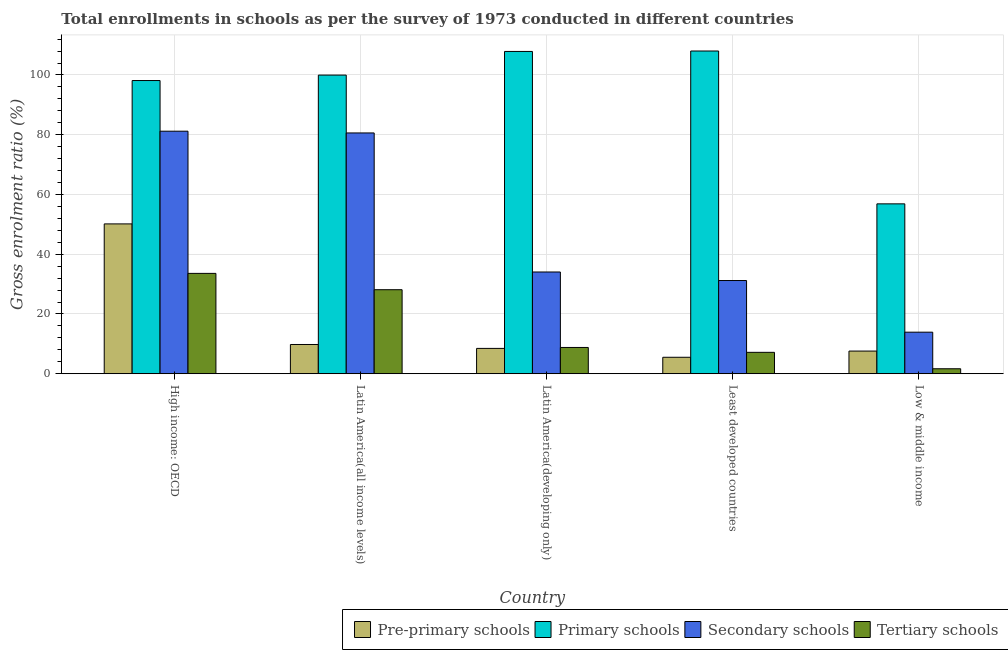How many different coloured bars are there?
Your answer should be very brief. 4. Are the number of bars per tick equal to the number of legend labels?
Offer a very short reply. Yes. Are the number of bars on each tick of the X-axis equal?
Your response must be concise. Yes. What is the label of the 3rd group of bars from the left?
Your response must be concise. Latin America(developing only). What is the gross enrolment ratio in secondary schools in High income: OECD?
Offer a very short reply. 81.17. Across all countries, what is the maximum gross enrolment ratio in primary schools?
Your response must be concise. 108.01. Across all countries, what is the minimum gross enrolment ratio in secondary schools?
Give a very brief answer. 13.91. In which country was the gross enrolment ratio in secondary schools maximum?
Your answer should be very brief. High income: OECD. In which country was the gross enrolment ratio in pre-primary schools minimum?
Make the answer very short. Least developed countries. What is the total gross enrolment ratio in secondary schools in the graph?
Offer a very short reply. 240.93. What is the difference between the gross enrolment ratio in secondary schools in High income: OECD and that in Least developed countries?
Your response must be concise. 49.98. What is the difference between the gross enrolment ratio in pre-primary schools in High income: OECD and the gross enrolment ratio in secondary schools in Latin America(developing only)?
Provide a short and direct response. 16.1. What is the average gross enrolment ratio in pre-primary schools per country?
Your response must be concise. 16.3. What is the difference between the gross enrolment ratio in secondary schools and gross enrolment ratio in tertiary schools in Latin America(all income levels)?
Provide a succinct answer. 52.47. What is the ratio of the gross enrolment ratio in primary schools in High income: OECD to that in Least developed countries?
Give a very brief answer. 0.91. Is the difference between the gross enrolment ratio in pre-primary schools in Latin America(all income levels) and Least developed countries greater than the difference between the gross enrolment ratio in tertiary schools in Latin America(all income levels) and Least developed countries?
Your answer should be compact. No. What is the difference between the highest and the second highest gross enrolment ratio in secondary schools?
Offer a terse response. 0.58. What is the difference between the highest and the lowest gross enrolment ratio in tertiary schools?
Ensure brevity in your answer.  31.92. Is the sum of the gross enrolment ratio in primary schools in High income: OECD and Least developed countries greater than the maximum gross enrolment ratio in secondary schools across all countries?
Your response must be concise. Yes. Is it the case that in every country, the sum of the gross enrolment ratio in primary schools and gross enrolment ratio in tertiary schools is greater than the sum of gross enrolment ratio in secondary schools and gross enrolment ratio in pre-primary schools?
Offer a very short reply. Yes. What does the 1st bar from the left in High income: OECD represents?
Ensure brevity in your answer.  Pre-primary schools. What does the 4th bar from the right in Latin America(all income levels) represents?
Keep it short and to the point. Pre-primary schools. How many countries are there in the graph?
Your response must be concise. 5. Does the graph contain any zero values?
Your answer should be very brief. No. Does the graph contain grids?
Make the answer very short. Yes. Where does the legend appear in the graph?
Make the answer very short. Bottom right. How are the legend labels stacked?
Keep it short and to the point. Horizontal. What is the title of the graph?
Keep it short and to the point. Total enrollments in schools as per the survey of 1973 conducted in different countries. What is the label or title of the X-axis?
Your response must be concise. Country. What is the Gross enrolment ratio (%) of Pre-primary schools in High income: OECD?
Your answer should be very brief. 50.15. What is the Gross enrolment ratio (%) in Primary schools in High income: OECD?
Provide a succinct answer. 98.13. What is the Gross enrolment ratio (%) in Secondary schools in High income: OECD?
Your answer should be very brief. 81.17. What is the Gross enrolment ratio (%) of Tertiary schools in High income: OECD?
Offer a very short reply. 33.59. What is the Gross enrolment ratio (%) of Pre-primary schools in Latin America(all income levels)?
Your answer should be very brief. 9.79. What is the Gross enrolment ratio (%) of Primary schools in Latin America(all income levels)?
Provide a succinct answer. 99.96. What is the Gross enrolment ratio (%) of Secondary schools in Latin America(all income levels)?
Provide a succinct answer. 80.59. What is the Gross enrolment ratio (%) in Tertiary schools in Latin America(all income levels)?
Offer a terse response. 28.12. What is the Gross enrolment ratio (%) of Pre-primary schools in Latin America(developing only)?
Make the answer very short. 8.48. What is the Gross enrolment ratio (%) of Primary schools in Latin America(developing only)?
Your response must be concise. 107.87. What is the Gross enrolment ratio (%) in Secondary schools in Latin America(developing only)?
Your answer should be very brief. 34.05. What is the Gross enrolment ratio (%) of Tertiary schools in Latin America(developing only)?
Make the answer very short. 8.79. What is the Gross enrolment ratio (%) in Pre-primary schools in Least developed countries?
Your answer should be compact. 5.51. What is the Gross enrolment ratio (%) in Primary schools in Least developed countries?
Provide a short and direct response. 108.01. What is the Gross enrolment ratio (%) in Secondary schools in Least developed countries?
Give a very brief answer. 31.2. What is the Gross enrolment ratio (%) in Tertiary schools in Least developed countries?
Give a very brief answer. 7.16. What is the Gross enrolment ratio (%) in Pre-primary schools in Low & middle income?
Keep it short and to the point. 7.59. What is the Gross enrolment ratio (%) in Primary schools in Low & middle income?
Provide a short and direct response. 56.86. What is the Gross enrolment ratio (%) in Secondary schools in Low & middle income?
Your answer should be very brief. 13.91. What is the Gross enrolment ratio (%) in Tertiary schools in Low & middle income?
Offer a terse response. 1.67. Across all countries, what is the maximum Gross enrolment ratio (%) in Pre-primary schools?
Make the answer very short. 50.15. Across all countries, what is the maximum Gross enrolment ratio (%) of Primary schools?
Provide a succinct answer. 108.01. Across all countries, what is the maximum Gross enrolment ratio (%) of Secondary schools?
Give a very brief answer. 81.17. Across all countries, what is the maximum Gross enrolment ratio (%) of Tertiary schools?
Your answer should be compact. 33.59. Across all countries, what is the minimum Gross enrolment ratio (%) of Pre-primary schools?
Offer a very short reply. 5.51. Across all countries, what is the minimum Gross enrolment ratio (%) in Primary schools?
Offer a terse response. 56.86. Across all countries, what is the minimum Gross enrolment ratio (%) of Secondary schools?
Your answer should be very brief. 13.91. Across all countries, what is the minimum Gross enrolment ratio (%) in Tertiary schools?
Offer a terse response. 1.67. What is the total Gross enrolment ratio (%) in Pre-primary schools in the graph?
Make the answer very short. 81.51. What is the total Gross enrolment ratio (%) of Primary schools in the graph?
Make the answer very short. 470.83. What is the total Gross enrolment ratio (%) of Secondary schools in the graph?
Offer a terse response. 240.93. What is the total Gross enrolment ratio (%) of Tertiary schools in the graph?
Ensure brevity in your answer.  79.34. What is the difference between the Gross enrolment ratio (%) in Pre-primary schools in High income: OECD and that in Latin America(all income levels)?
Offer a terse response. 40.36. What is the difference between the Gross enrolment ratio (%) in Primary schools in High income: OECD and that in Latin America(all income levels)?
Make the answer very short. -1.83. What is the difference between the Gross enrolment ratio (%) of Secondary schools in High income: OECD and that in Latin America(all income levels)?
Your answer should be very brief. 0.58. What is the difference between the Gross enrolment ratio (%) in Tertiary schools in High income: OECD and that in Latin America(all income levels)?
Ensure brevity in your answer.  5.47. What is the difference between the Gross enrolment ratio (%) of Pre-primary schools in High income: OECD and that in Latin America(developing only)?
Provide a short and direct response. 41.67. What is the difference between the Gross enrolment ratio (%) in Primary schools in High income: OECD and that in Latin America(developing only)?
Provide a succinct answer. -9.74. What is the difference between the Gross enrolment ratio (%) of Secondary schools in High income: OECD and that in Latin America(developing only)?
Ensure brevity in your answer.  47.12. What is the difference between the Gross enrolment ratio (%) in Tertiary schools in High income: OECD and that in Latin America(developing only)?
Your answer should be compact. 24.8. What is the difference between the Gross enrolment ratio (%) of Pre-primary schools in High income: OECD and that in Least developed countries?
Ensure brevity in your answer.  44.64. What is the difference between the Gross enrolment ratio (%) of Primary schools in High income: OECD and that in Least developed countries?
Your answer should be very brief. -9.89. What is the difference between the Gross enrolment ratio (%) in Secondary schools in High income: OECD and that in Least developed countries?
Keep it short and to the point. 49.98. What is the difference between the Gross enrolment ratio (%) of Tertiary schools in High income: OECD and that in Least developed countries?
Ensure brevity in your answer.  26.43. What is the difference between the Gross enrolment ratio (%) of Pre-primary schools in High income: OECD and that in Low & middle income?
Your answer should be compact. 42.56. What is the difference between the Gross enrolment ratio (%) of Primary schools in High income: OECD and that in Low & middle income?
Offer a very short reply. 41.27. What is the difference between the Gross enrolment ratio (%) of Secondary schools in High income: OECD and that in Low & middle income?
Your answer should be compact. 67.27. What is the difference between the Gross enrolment ratio (%) of Tertiary schools in High income: OECD and that in Low & middle income?
Your answer should be very brief. 31.92. What is the difference between the Gross enrolment ratio (%) of Pre-primary schools in Latin America(all income levels) and that in Latin America(developing only)?
Your response must be concise. 1.31. What is the difference between the Gross enrolment ratio (%) in Primary schools in Latin America(all income levels) and that in Latin America(developing only)?
Your response must be concise. -7.91. What is the difference between the Gross enrolment ratio (%) in Secondary schools in Latin America(all income levels) and that in Latin America(developing only)?
Make the answer very short. 46.54. What is the difference between the Gross enrolment ratio (%) of Tertiary schools in Latin America(all income levels) and that in Latin America(developing only)?
Offer a very short reply. 19.33. What is the difference between the Gross enrolment ratio (%) of Pre-primary schools in Latin America(all income levels) and that in Least developed countries?
Ensure brevity in your answer.  4.27. What is the difference between the Gross enrolment ratio (%) in Primary schools in Latin America(all income levels) and that in Least developed countries?
Provide a succinct answer. -8.06. What is the difference between the Gross enrolment ratio (%) of Secondary schools in Latin America(all income levels) and that in Least developed countries?
Provide a short and direct response. 49.39. What is the difference between the Gross enrolment ratio (%) in Tertiary schools in Latin America(all income levels) and that in Least developed countries?
Your response must be concise. 20.96. What is the difference between the Gross enrolment ratio (%) in Pre-primary schools in Latin America(all income levels) and that in Low & middle income?
Give a very brief answer. 2.2. What is the difference between the Gross enrolment ratio (%) of Primary schools in Latin America(all income levels) and that in Low & middle income?
Ensure brevity in your answer.  43.1. What is the difference between the Gross enrolment ratio (%) of Secondary schools in Latin America(all income levels) and that in Low & middle income?
Make the answer very short. 66.68. What is the difference between the Gross enrolment ratio (%) of Tertiary schools in Latin America(all income levels) and that in Low & middle income?
Your answer should be very brief. 26.45. What is the difference between the Gross enrolment ratio (%) of Pre-primary schools in Latin America(developing only) and that in Least developed countries?
Make the answer very short. 2.97. What is the difference between the Gross enrolment ratio (%) of Primary schools in Latin America(developing only) and that in Least developed countries?
Your response must be concise. -0.15. What is the difference between the Gross enrolment ratio (%) in Secondary schools in Latin America(developing only) and that in Least developed countries?
Provide a short and direct response. 2.85. What is the difference between the Gross enrolment ratio (%) in Tertiary schools in Latin America(developing only) and that in Least developed countries?
Offer a very short reply. 1.63. What is the difference between the Gross enrolment ratio (%) in Pre-primary schools in Latin America(developing only) and that in Low & middle income?
Your response must be concise. 0.89. What is the difference between the Gross enrolment ratio (%) of Primary schools in Latin America(developing only) and that in Low & middle income?
Your answer should be very brief. 51.01. What is the difference between the Gross enrolment ratio (%) of Secondary schools in Latin America(developing only) and that in Low & middle income?
Make the answer very short. 20.14. What is the difference between the Gross enrolment ratio (%) in Tertiary schools in Latin America(developing only) and that in Low & middle income?
Give a very brief answer. 7.13. What is the difference between the Gross enrolment ratio (%) in Pre-primary schools in Least developed countries and that in Low & middle income?
Your answer should be very brief. -2.07. What is the difference between the Gross enrolment ratio (%) of Primary schools in Least developed countries and that in Low & middle income?
Your answer should be very brief. 51.16. What is the difference between the Gross enrolment ratio (%) of Secondary schools in Least developed countries and that in Low & middle income?
Your answer should be compact. 17.29. What is the difference between the Gross enrolment ratio (%) of Tertiary schools in Least developed countries and that in Low & middle income?
Provide a succinct answer. 5.5. What is the difference between the Gross enrolment ratio (%) in Pre-primary schools in High income: OECD and the Gross enrolment ratio (%) in Primary schools in Latin America(all income levels)?
Provide a succinct answer. -49.81. What is the difference between the Gross enrolment ratio (%) in Pre-primary schools in High income: OECD and the Gross enrolment ratio (%) in Secondary schools in Latin America(all income levels)?
Give a very brief answer. -30.45. What is the difference between the Gross enrolment ratio (%) in Pre-primary schools in High income: OECD and the Gross enrolment ratio (%) in Tertiary schools in Latin America(all income levels)?
Your answer should be compact. 22.03. What is the difference between the Gross enrolment ratio (%) in Primary schools in High income: OECD and the Gross enrolment ratio (%) in Secondary schools in Latin America(all income levels)?
Offer a terse response. 17.54. What is the difference between the Gross enrolment ratio (%) in Primary schools in High income: OECD and the Gross enrolment ratio (%) in Tertiary schools in Latin America(all income levels)?
Ensure brevity in your answer.  70.01. What is the difference between the Gross enrolment ratio (%) of Secondary schools in High income: OECD and the Gross enrolment ratio (%) of Tertiary schools in Latin America(all income levels)?
Your answer should be very brief. 53.05. What is the difference between the Gross enrolment ratio (%) in Pre-primary schools in High income: OECD and the Gross enrolment ratio (%) in Primary schools in Latin America(developing only)?
Provide a short and direct response. -57.72. What is the difference between the Gross enrolment ratio (%) in Pre-primary schools in High income: OECD and the Gross enrolment ratio (%) in Secondary schools in Latin America(developing only)?
Offer a very short reply. 16.1. What is the difference between the Gross enrolment ratio (%) in Pre-primary schools in High income: OECD and the Gross enrolment ratio (%) in Tertiary schools in Latin America(developing only)?
Your answer should be very brief. 41.35. What is the difference between the Gross enrolment ratio (%) of Primary schools in High income: OECD and the Gross enrolment ratio (%) of Secondary schools in Latin America(developing only)?
Keep it short and to the point. 64.08. What is the difference between the Gross enrolment ratio (%) in Primary schools in High income: OECD and the Gross enrolment ratio (%) in Tertiary schools in Latin America(developing only)?
Give a very brief answer. 89.33. What is the difference between the Gross enrolment ratio (%) of Secondary schools in High income: OECD and the Gross enrolment ratio (%) of Tertiary schools in Latin America(developing only)?
Your response must be concise. 72.38. What is the difference between the Gross enrolment ratio (%) in Pre-primary schools in High income: OECD and the Gross enrolment ratio (%) in Primary schools in Least developed countries?
Offer a terse response. -57.87. What is the difference between the Gross enrolment ratio (%) in Pre-primary schools in High income: OECD and the Gross enrolment ratio (%) in Secondary schools in Least developed countries?
Offer a very short reply. 18.95. What is the difference between the Gross enrolment ratio (%) in Pre-primary schools in High income: OECD and the Gross enrolment ratio (%) in Tertiary schools in Least developed countries?
Make the answer very short. 42.98. What is the difference between the Gross enrolment ratio (%) of Primary schools in High income: OECD and the Gross enrolment ratio (%) of Secondary schools in Least developed countries?
Your response must be concise. 66.93. What is the difference between the Gross enrolment ratio (%) of Primary schools in High income: OECD and the Gross enrolment ratio (%) of Tertiary schools in Least developed countries?
Keep it short and to the point. 90.96. What is the difference between the Gross enrolment ratio (%) of Secondary schools in High income: OECD and the Gross enrolment ratio (%) of Tertiary schools in Least developed countries?
Offer a very short reply. 74.01. What is the difference between the Gross enrolment ratio (%) in Pre-primary schools in High income: OECD and the Gross enrolment ratio (%) in Primary schools in Low & middle income?
Offer a terse response. -6.71. What is the difference between the Gross enrolment ratio (%) in Pre-primary schools in High income: OECD and the Gross enrolment ratio (%) in Secondary schools in Low & middle income?
Offer a very short reply. 36.24. What is the difference between the Gross enrolment ratio (%) in Pre-primary schools in High income: OECD and the Gross enrolment ratio (%) in Tertiary schools in Low & middle income?
Ensure brevity in your answer.  48.48. What is the difference between the Gross enrolment ratio (%) of Primary schools in High income: OECD and the Gross enrolment ratio (%) of Secondary schools in Low & middle income?
Keep it short and to the point. 84.22. What is the difference between the Gross enrolment ratio (%) in Primary schools in High income: OECD and the Gross enrolment ratio (%) in Tertiary schools in Low & middle income?
Give a very brief answer. 96.46. What is the difference between the Gross enrolment ratio (%) in Secondary schools in High income: OECD and the Gross enrolment ratio (%) in Tertiary schools in Low & middle income?
Offer a very short reply. 79.51. What is the difference between the Gross enrolment ratio (%) of Pre-primary schools in Latin America(all income levels) and the Gross enrolment ratio (%) of Primary schools in Latin America(developing only)?
Ensure brevity in your answer.  -98.08. What is the difference between the Gross enrolment ratio (%) in Pre-primary schools in Latin America(all income levels) and the Gross enrolment ratio (%) in Secondary schools in Latin America(developing only)?
Give a very brief answer. -24.27. What is the difference between the Gross enrolment ratio (%) of Pre-primary schools in Latin America(all income levels) and the Gross enrolment ratio (%) of Tertiary schools in Latin America(developing only)?
Ensure brevity in your answer.  0.99. What is the difference between the Gross enrolment ratio (%) of Primary schools in Latin America(all income levels) and the Gross enrolment ratio (%) of Secondary schools in Latin America(developing only)?
Your answer should be compact. 65.9. What is the difference between the Gross enrolment ratio (%) of Primary schools in Latin America(all income levels) and the Gross enrolment ratio (%) of Tertiary schools in Latin America(developing only)?
Provide a succinct answer. 91.16. What is the difference between the Gross enrolment ratio (%) in Secondary schools in Latin America(all income levels) and the Gross enrolment ratio (%) in Tertiary schools in Latin America(developing only)?
Make the answer very short. 71.8. What is the difference between the Gross enrolment ratio (%) of Pre-primary schools in Latin America(all income levels) and the Gross enrolment ratio (%) of Primary schools in Least developed countries?
Make the answer very short. -98.23. What is the difference between the Gross enrolment ratio (%) in Pre-primary schools in Latin America(all income levels) and the Gross enrolment ratio (%) in Secondary schools in Least developed countries?
Keep it short and to the point. -21.41. What is the difference between the Gross enrolment ratio (%) in Pre-primary schools in Latin America(all income levels) and the Gross enrolment ratio (%) in Tertiary schools in Least developed countries?
Your answer should be very brief. 2.62. What is the difference between the Gross enrolment ratio (%) of Primary schools in Latin America(all income levels) and the Gross enrolment ratio (%) of Secondary schools in Least developed countries?
Give a very brief answer. 68.76. What is the difference between the Gross enrolment ratio (%) of Primary schools in Latin America(all income levels) and the Gross enrolment ratio (%) of Tertiary schools in Least developed countries?
Offer a terse response. 92.79. What is the difference between the Gross enrolment ratio (%) of Secondary schools in Latin America(all income levels) and the Gross enrolment ratio (%) of Tertiary schools in Least developed countries?
Give a very brief answer. 73.43. What is the difference between the Gross enrolment ratio (%) of Pre-primary schools in Latin America(all income levels) and the Gross enrolment ratio (%) of Primary schools in Low & middle income?
Offer a terse response. -47.07. What is the difference between the Gross enrolment ratio (%) in Pre-primary schools in Latin America(all income levels) and the Gross enrolment ratio (%) in Secondary schools in Low & middle income?
Your answer should be compact. -4.12. What is the difference between the Gross enrolment ratio (%) in Pre-primary schools in Latin America(all income levels) and the Gross enrolment ratio (%) in Tertiary schools in Low & middle income?
Keep it short and to the point. 8.12. What is the difference between the Gross enrolment ratio (%) in Primary schools in Latin America(all income levels) and the Gross enrolment ratio (%) in Secondary schools in Low & middle income?
Provide a short and direct response. 86.05. What is the difference between the Gross enrolment ratio (%) in Primary schools in Latin America(all income levels) and the Gross enrolment ratio (%) in Tertiary schools in Low & middle income?
Keep it short and to the point. 98.29. What is the difference between the Gross enrolment ratio (%) in Secondary schools in Latin America(all income levels) and the Gross enrolment ratio (%) in Tertiary schools in Low & middle income?
Offer a terse response. 78.92. What is the difference between the Gross enrolment ratio (%) in Pre-primary schools in Latin America(developing only) and the Gross enrolment ratio (%) in Primary schools in Least developed countries?
Give a very brief answer. -99.54. What is the difference between the Gross enrolment ratio (%) in Pre-primary schools in Latin America(developing only) and the Gross enrolment ratio (%) in Secondary schools in Least developed countries?
Offer a very short reply. -22.72. What is the difference between the Gross enrolment ratio (%) of Pre-primary schools in Latin America(developing only) and the Gross enrolment ratio (%) of Tertiary schools in Least developed countries?
Your answer should be very brief. 1.31. What is the difference between the Gross enrolment ratio (%) of Primary schools in Latin America(developing only) and the Gross enrolment ratio (%) of Secondary schools in Least developed countries?
Offer a very short reply. 76.67. What is the difference between the Gross enrolment ratio (%) in Primary schools in Latin America(developing only) and the Gross enrolment ratio (%) in Tertiary schools in Least developed countries?
Your answer should be very brief. 100.7. What is the difference between the Gross enrolment ratio (%) of Secondary schools in Latin America(developing only) and the Gross enrolment ratio (%) of Tertiary schools in Least developed countries?
Your answer should be very brief. 26.89. What is the difference between the Gross enrolment ratio (%) in Pre-primary schools in Latin America(developing only) and the Gross enrolment ratio (%) in Primary schools in Low & middle income?
Offer a very short reply. -48.38. What is the difference between the Gross enrolment ratio (%) of Pre-primary schools in Latin America(developing only) and the Gross enrolment ratio (%) of Secondary schools in Low & middle income?
Your response must be concise. -5.43. What is the difference between the Gross enrolment ratio (%) in Pre-primary schools in Latin America(developing only) and the Gross enrolment ratio (%) in Tertiary schools in Low & middle income?
Give a very brief answer. 6.81. What is the difference between the Gross enrolment ratio (%) in Primary schools in Latin America(developing only) and the Gross enrolment ratio (%) in Secondary schools in Low & middle income?
Make the answer very short. 93.96. What is the difference between the Gross enrolment ratio (%) in Primary schools in Latin America(developing only) and the Gross enrolment ratio (%) in Tertiary schools in Low & middle income?
Keep it short and to the point. 106.2. What is the difference between the Gross enrolment ratio (%) in Secondary schools in Latin America(developing only) and the Gross enrolment ratio (%) in Tertiary schools in Low & middle income?
Offer a terse response. 32.38. What is the difference between the Gross enrolment ratio (%) in Pre-primary schools in Least developed countries and the Gross enrolment ratio (%) in Primary schools in Low & middle income?
Offer a very short reply. -51.34. What is the difference between the Gross enrolment ratio (%) in Pre-primary schools in Least developed countries and the Gross enrolment ratio (%) in Secondary schools in Low & middle income?
Offer a terse response. -8.4. What is the difference between the Gross enrolment ratio (%) in Pre-primary schools in Least developed countries and the Gross enrolment ratio (%) in Tertiary schools in Low & middle income?
Your answer should be very brief. 3.84. What is the difference between the Gross enrolment ratio (%) in Primary schools in Least developed countries and the Gross enrolment ratio (%) in Secondary schools in Low & middle income?
Your answer should be compact. 94.11. What is the difference between the Gross enrolment ratio (%) in Primary schools in Least developed countries and the Gross enrolment ratio (%) in Tertiary schools in Low & middle income?
Offer a terse response. 106.35. What is the difference between the Gross enrolment ratio (%) of Secondary schools in Least developed countries and the Gross enrolment ratio (%) of Tertiary schools in Low & middle income?
Your response must be concise. 29.53. What is the average Gross enrolment ratio (%) in Pre-primary schools per country?
Offer a terse response. 16.3. What is the average Gross enrolment ratio (%) in Primary schools per country?
Your answer should be compact. 94.17. What is the average Gross enrolment ratio (%) in Secondary schools per country?
Your answer should be compact. 48.19. What is the average Gross enrolment ratio (%) of Tertiary schools per country?
Offer a very short reply. 15.87. What is the difference between the Gross enrolment ratio (%) in Pre-primary schools and Gross enrolment ratio (%) in Primary schools in High income: OECD?
Make the answer very short. -47.98. What is the difference between the Gross enrolment ratio (%) of Pre-primary schools and Gross enrolment ratio (%) of Secondary schools in High income: OECD?
Provide a succinct answer. -31.03. What is the difference between the Gross enrolment ratio (%) of Pre-primary schools and Gross enrolment ratio (%) of Tertiary schools in High income: OECD?
Keep it short and to the point. 16.56. What is the difference between the Gross enrolment ratio (%) in Primary schools and Gross enrolment ratio (%) in Secondary schools in High income: OECD?
Offer a very short reply. 16.95. What is the difference between the Gross enrolment ratio (%) in Primary schools and Gross enrolment ratio (%) in Tertiary schools in High income: OECD?
Your response must be concise. 64.54. What is the difference between the Gross enrolment ratio (%) of Secondary schools and Gross enrolment ratio (%) of Tertiary schools in High income: OECD?
Your answer should be very brief. 47.58. What is the difference between the Gross enrolment ratio (%) in Pre-primary schools and Gross enrolment ratio (%) in Primary schools in Latin America(all income levels)?
Your response must be concise. -90.17. What is the difference between the Gross enrolment ratio (%) in Pre-primary schools and Gross enrolment ratio (%) in Secondary schools in Latin America(all income levels)?
Give a very brief answer. -70.81. What is the difference between the Gross enrolment ratio (%) in Pre-primary schools and Gross enrolment ratio (%) in Tertiary schools in Latin America(all income levels)?
Provide a short and direct response. -18.34. What is the difference between the Gross enrolment ratio (%) of Primary schools and Gross enrolment ratio (%) of Secondary schools in Latin America(all income levels)?
Offer a terse response. 19.36. What is the difference between the Gross enrolment ratio (%) in Primary schools and Gross enrolment ratio (%) in Tertiary schools in Latin America(all income levels)?
Keep it short and to the point. 71.83. What is the difference between the Gross enrolment ratio (%) of Secondary schools and Gross enrolment ratio (%) of Tertiary schools in Latin America(all income levels)?
Your answer should be very brief. 52.47. What is the difference between the Gross enrolment ratio (%) in Pre-primary schools and Gross enrolment ratio (%) in Primary schools in Latin America(developing only)?
Offer a very short reply. -99.39. What is the difference between the Gross enrolment ratio (%) of Pre-primary schools and Gross enrolment ratio (%) of Secondary schools in Latin America(developing only)?
Offer a very short reply. -25.57. What is the difference between the Gross enrolment ratio (%) in Pre-primary schools and Gross enrolment ratio (%) in Tertiary schools in Latin America(developing only)?
Your answer should be very brief. -0.32. What is the difference between the Gross enrolment ratio (%) of Primary schools and Gross enrolment ratio (%) of Secondary schools in Latin America(developing only)?
Give a very brief answer. 73.82. What is the difference between the Gross enrolment ratio (%) of Primary schools and Gross enrolment ratio (%) of Tertiary schools in Latin America(developing only)?
Your response must be concise. 99.07. What is the difference between the Gross enrolment ratio (%) in Secondary schools and Gross enrolment ratio (%) in Tertiary schools in Latin America(developing only)?
Offer a very short reply. 25.26. What is the difference between the Gross enrolment ratio (%) in Pre-primary schools and Gross enrolment ratio (%) in Primary schools in Least developed countries?
Give a very brief answer. -102.5. What is the difference between the Gross enrolment ratio (%) in Pre-primary schools and Gross enrolment ratio (%) in Secondary schools in Least developed countries?
Your response must be concise. -25.69. What is the difference between the Gross enrolment ratio (%) in Pre-primary schools and Gross enrolment ratio (%) in Tertiary schools in Least developed countries?
Your answer should be very brief. -1.65. What is the difference between the Gross enrolment ratio (%) of Primary schools and Gross enrolment ratio (%) of Secondary schools in Least developed countries?
Make the answer very short. 76.81. What is the difference between the Gross enrolment ratio (%) of Primary schools and Gross enrolment ratio (%) of Tertiary schools in Least developed countries?
Your answer should be very brief. 100.85. What is the difference between the Gross enrolment ratio (%) of Secondary schools and Gross enrolment ratio (%) of Tertiary schools in Least developed countries?
Give a very brief answer. 24.04. What is the difference between the Gross enrolment ratio (%) of Pre-primary schools and Gross enrolment ratio (%) of Primary schools in Low & middle income?
Offer a very short reply. -49.27. What is the difference between the Gross enrolment ratio (%) in Pre-primary schools and Gross enrolment ratio (%) in Secondary schools in Low & middle income?
Give a very brief answer. -6.32. What is the difference between the Gross enrolment ratio (%) in Pre-primary schools and Gross enrolment ratio (%) in Tertiary schools in Low & middle income?
Provide a succinct answer. 5.92. What is the difference between the Gross enrolment ratio (%) in Primary schools and Gross enrolment ratio (%) in Secondary schools in Low & middle income?
Offer a terse response. 42.95. What is the difference between the Gross enrolment ratio (%) of Primary schools and Gross enrolment ratio (%) of Tertiary schools in Low & middle income?
Provide a succinct answer. 55.19. What is the difference between the Gross enrolment ratio (%) of Secondary schools and Gross enrolment ratio (%) of Tertiary schools in Low & middle income?
Give a very brief answer. 12.24. What is the ratio of the Gross enrolment ratio (%) of Pre-primary schools in High income: OECD to that in Latin America(all income levels)?
Your answer should be very brief. 5.12. What is the ratio of the Gross enrolment ratio (%) of Primary schools in High income: OECD to that in Latin America(all income levels)?
Your answer should be very brief. 0.98. What is the ratio of the Gross enrolment ratio (%) of Tertiary schools in High income: OECD to that in Latin America(all income levels)?
Offer a very short reply. 1.19. What is the ratio of the Gross enrolment ratio (%) of Pre-primary schools in High income: OECD to that in Latin America(developing only)?
Keep it short and to the point. 5.91. What is the ratio of the Gross enrolment ratio (%) in Primary schools in High income: OECD to that in Latin America(developing only)?
Offer a terse response. 0.91. What is the ratio of the Gross enrolment ratio (%) of Secondary schools in High income: OECD to that in Latin America(developing only)?
Keep it short and to the point. 2.38. What is the ratio of the Gross enrolment ratio (%) in Tertiary schools in High income: OECD to that in Latin America(developing only)?
Provide a short and direct response. 3.82. What is the ratio of the Gross enrolment ratio (%) of Pre-primary schools in High income: OECD to that in Least developed countries?
Your answer should be compact. 9.1. What is the ratio of the Gross enrolment ratio (%) of Primary schools in High income: OECD to that in Least developed countries?
Provide a short and direct response. 0.91. What is the ratio of the Gross enrolment ratio (%) in Secondary schools in High income: OECD to that in Least developed countries?
Offer a terse response. 2.6. What is the ratio of the Gross enrolment ratio (%) of Tertiary schools in High income: OECD to that in Least developed countries?
Provide a short and direct response. 4.69. What is the ratio of the Gross enrolment ratio (%) in Pre-primary schools in High income: OECD to that in Low & middle income?
Offer a very short reply. 6.61. What is the ratio of the Gross enrolment ratio (%) in Primary schools in High income: OECD to that in Low & middle income?
Your answer should be compact. 1.73. What is the ratio of the Gross enrolment ratio (%) of Secondary schools in High income: OECD to that in Low & middle income?
Your answer should be compact. 5.84. What is the ratio of the Gross enrolment ratio (%) in Tertiary schools in High income: OECD to that in Low & middle income?
Provide a short and direct response. 20.13. What is the ratio of the Gross enrolment ratio (%) of Pre-primary schools in Latin America(all income levels) to that in Latin America(developing only)?
Provide a succinct answer. 1.15. What is the ratio of the Gross enrolment ratio (%) of Primary schools in Latin America(all income levels) to that in Latin America(developing only)?
Provide a succinct answer. 0.93. What is the ratio of the Gross enrolment ratio (%) in Secondary schools in Latin America(all income levels) to that in Latin America(developing only)?
Provide a succinct answer. 2.37. What is the ratio of the Gross enrolment ratio (%) of Tertiary schools in Latin America(all income levels) to that in Latin America(developing only)?
Give a very brief answer. 3.2. What is the ratio of the Gross enrolment ratio (%) in Pre-primary schools in Latin America(all income levels) to that in Least developed countries?
Make the answer very short. 1.78. What is the ratio of the Gross enrolment ratio (%) of Primary schools in Latin America(all income levels) to that in Least developed countries?
Your response must be concise. 0.93. What is the ratio of the Gross enrolment ratio (%) of Secondary schools in Latin America(all income levels) to that in Least developed countries?
Keep it short and to the point. 2.58. What is the ratio of the Gross enrolment ratio (%) of Tertiary schools in Latin America(all income levels) to that in Least developed countries?
Your response must be concise. 3.93. What is the ratio of the Gross enrolment ratio (%) of Pre-primary schools in Latin America(all income levels) to that in Low & middle income?
Make the answer very short. 1.29. What is the ratio of the Gross enrolment ratio (%) in Primary schools in Latin America(all income levels) to that in Low & middle income?
Ensure brevity in your answer.  1.76. What is the ratio of the Gross enrolment ratio (%) of Secondary schools in Latin America(all income levels) to that in Low & middle income?
Provide a short and direct response. 5.79. What is the ratio of the Gross enrolment ratio (%) in Tertiary schools in Latin America(all income levels) to that in Low & middle income?
Ensure brevity in your answer.  16.85. What is the ratio of the Gross enrolment ratio (%) of Pre-primary schools in Latin America(developing only) to that in Least developed countries?
Make the answer very short. 1.54. What is the ratio of the Gross enrolment ratio (%) in Primary schools in Latin America(developing only) to that in Least developed countries?
Make the answer very short. 1. What is the ratio of the Gross enrolment ratio (%) of Secondary schools in Latin America(developing only) to that in Least developed countries?
Offer a terse response. 1.09. What is the ratio of the Gross enrolment ratio (%) of Tertiary schools in Latin America(developing only) to that in Least developed countries?
Give a very brief answer. 1.23. What is the ratio of the Gross enrolment ratio (%) in Pre-primary schools in Latin America(developing only) to that in Low & middle income?
Your response must be concise. 1.12. What is the ratio of the Gross enrolment ratio (%) in Primary schools in Latin America(developing only) to that in Low & middle income?
Make the answer very short. 1.9. What is the ratio of the Gross enrolment ratio (%) of Secondary schools in Latin America(developing only) to that in Low & middle income?
Ensure brevity in your answer.  2.45. What is the ratio of the Gross enrolment ratio (%) of Tertiary schools in Latin America(developing only) to that in Low & middle income?
Your answer should be very brief. 5.27. What is the ratio of the Gross enrolment ratio (%) in Pre-primary schools in Least developed countries to that in Low & middle income?
Provide a short and direct response. 0.73. What is the ratio of the Gross enrolment ratio (%) in Primary schools in Least developed countries to that in Low & middle income?
Your answer should be compact. 1.9. What is the ratio of the Gross enrolment ratio (%) in Secondary schools in Least developed countries to that in Low & middle income?
Give a very brief answer. 2.24. What is the ratio of the Gross enrolment ratio (%) of Tertiary schools in Least developed countries to that in Low & middle income?
Keep it short and to the point. 4.29. What is the difference between the highest and the second highest Gross enrolment ratio (%) in Pre-primary schools?
Make the answer very short. 40.36. What is the difference between the highest and the second highest Gross enrolment ratio (%) in Primary schools?
Offer a terse response. 0.15. What is the difference between the highest and the second highest Gross enrolment ratio (%) of Secondary schools?
Give a very brief answer. 0.58. What is the difference between the highest and the second highest Gross enrolment ratio (%) of Tertiary schools?
Ensure brevity in your answer.  5.47. What is the difference between the highest and the lowest Gross enrolment ratio (%) in Pre-primary schools?
Keep it short and to the point. 44.64. What is the difference between the highest and the lowest Gross enrolment ratio (%) in Primary schools?
Offer a terse response. 51.16. What is the difference between the highest and the lowest Gross enrolment ratio (%) of Secondary schools?
Offer a very short reply. 67.27. What is the difference between the highest and the lowest Gross enrolment ratio (%) in Tertiary schools?
Make the answer very short. 31.92. 